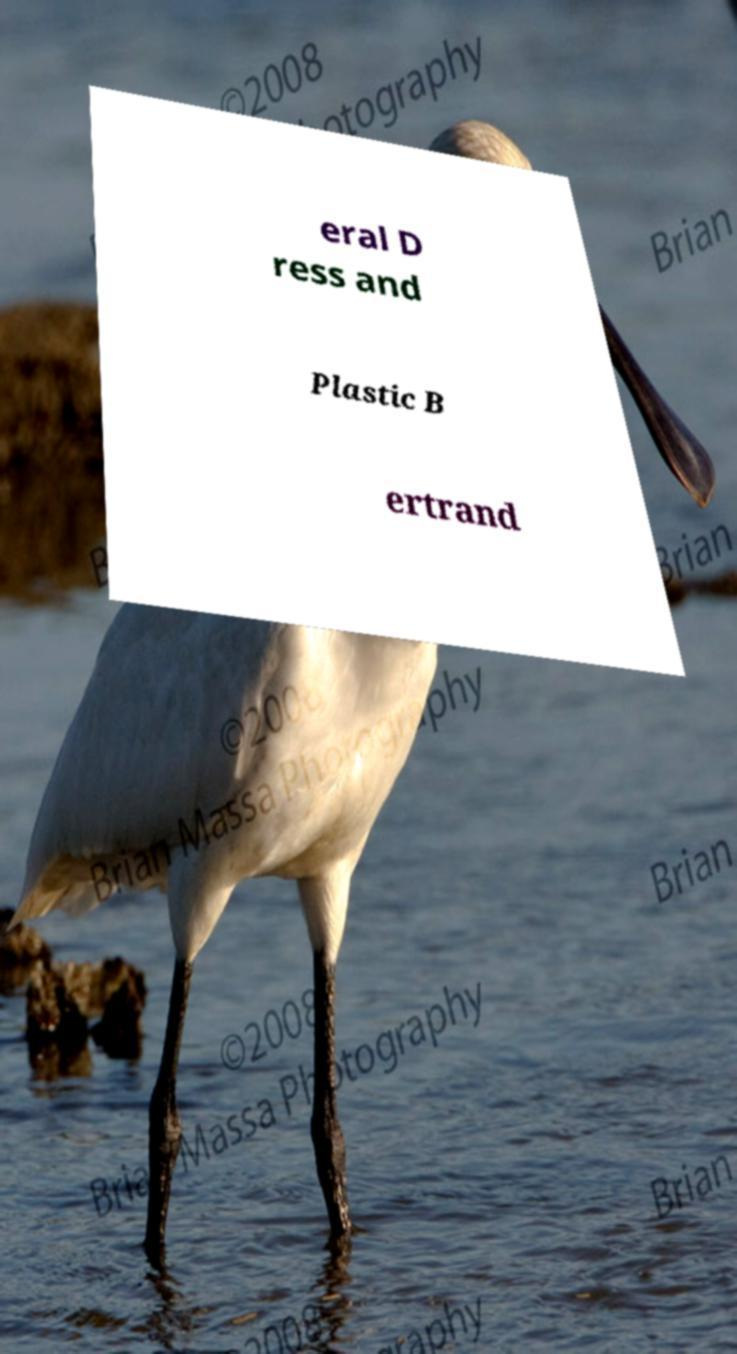I need the written content from this picture converted into text. Can you do that? eral D ress and Plastic B ertrand 